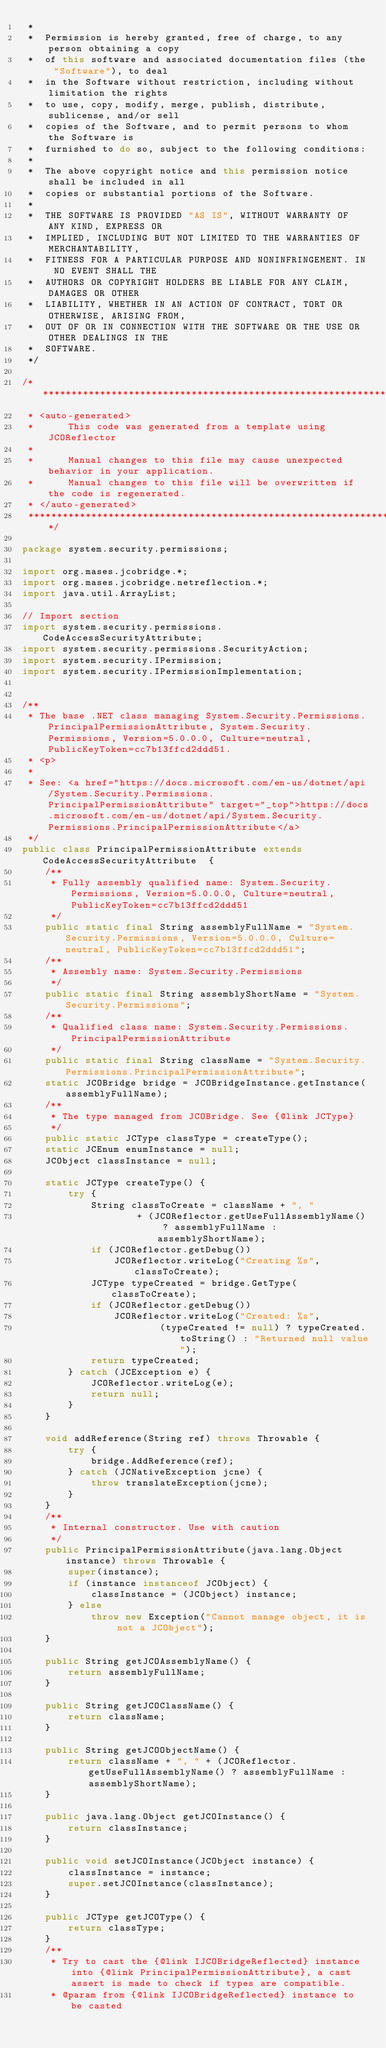<code> <loc_0><loc_0><loc_500><loc_500><_Java_> *
 *  Permission is hereby granted, free of charge, to any person obtaining a copy
 *  of this software and associated documentation files (the "Software"), to deal
 *  in the Software without restriction, including without limitation the rights
 *  to use, copy, modify, merge, publish, distribute, sublicense, and/or sell
 *  copies of the Software, and to permit persons to whom the Software is
 *  furnished to do so, subject to the following conditions:
 *
 *  The above copyright notice and this permission notice shall be included in all
 *  copies or substantial portions of the Software.
 *
 *  THE SOFTWARE IS PROVIDED "AS IS", WITHOUT WARRANTY OF ANY KIND, EXPRESS OR
 *  IMPLIED, INCLUDING BUT NOT LIMITED TO THE WARRANTIES OF MERCHANTABILITY,
 *  FITNESS FOR A PARTICULAR PURPOSE AND NONINFRINGEMENT. IN NO EVENT SHALL THE
 *  AUTHORS OR COPYRIGHT HOLDERS BE LIABLE FOR ANY CLAIM, DAMAGES OR OTHER
 *  LIABILITY, WHETHER IN AN ACTION OF CONTRACT, TORT OR OTHERWISE, ARISING FROM,
 *  OUT OF OR IN CONNECTION WITH THE SOFTWARE OR THE USE OR OTHER DEALINGS IN THE
 *  SOFTWARE.
 */

/**************************************************************************************
 * <auto-generated>
 *      This code was generated from a template using JCOReflector
 * 
 *      Manual changes to this file may cause unexpected behavior in your application.
 *      Manual changes to this file will be overwritten if the code is regenerated.
 * </auto-generated>
 *************************************************************************************/

package system.security.permissions;

import org.mases.jcobridge.*;
import org.mases.jcobridge.netreflection.*;
import java.util.ArrayList;

// Import section
import system.security.permissions.CodeAccessSecurityAttribute;
import system.security.permissions.SecurityAction;
import system.security.IPermission;
import system.security.IPermissionImplementation;


/**
 * The base .NET class managing System.Security.Permissions.PrincipalPermissionAttribute, System.Security.Permissions, Version=5.0.0.0, Culture=neutral, PublicKeyToken=cc7b13ffcd2ddd51.
 * <p>
 * 
 * See: <a href="https://docs.microsoft.com/en-us/dotnet/api/System.Security.Permissions.PrincipalPermissionAttribute" target="_top">https://docs.microsoft.com/en-us/dotnet/api/System.Security.Permissions.PrincipalPermissionAttribute</a>
 */
public class PrincipalPermissionAttribute extends CodeAccessSecurityAttribute  {
    /**
     * Fully assembly qualified name: System.Security.Permissions, Version=5.0.0.0, Culture=neutral, PublicKeyToken=cc7b13ffcd2ddd51
     */
    public static final String assemblyFullName = "System.Security.Permissions, Version=5.0.0.0, Culture=neutral, PublicKeyToken=cc7b13ffcd2ddd51";
    /**
     * Assembly name: System.Security.Permissions
     */
    public static final String assemblyShortName = "System.Security.Permissions";
    /**
     * Qualified class name: System.Security.Permissions.PrincipalPermissionAttribute
     */
    public static final String className = "System.Security.Permissions.PrincipalPermissionAttribute";
    static JCOBridge bridge = JCOBridgeInstance.getInstance(assemblyFullName);
    /**
     * The type managed from JCOBridge. See {@link JCType}
     */
    public static JCType classType = createType();
    static JCEnum enumInstance = null;
    JCObject classInstance = null;

    static JCType createType() {
        try {
            String classToCreate = className + ", "
                    + (JCOReflector.getUseFullAssemblyName() ? assemblyFullName : assemblyShortName);
            if (JCOReflector.getDebug())
                JCOReflector.writeLog("Creating %s", classToCreate);
            JCType typeCreated = bridge.GetType(classToCreate);
            if (JCOReflector.getDebug())
                JCOReflector.writeLog("Created: %s",
                        (typeCreated != null) ? typeCreated.toString() : "Returned null value");
            return typeCreated;
        } catch (JCException e) {
            JCOReflector.writeLog(e);
            return null;
        }
    }

    void addReference(String ref) throws Throwable {
        try {
            bridge.AddReference(ref);
        } catch (JCNativeException jcne) {
            throw translateException(jcne);
        }
    }
    /**
     * Internal constructor. Use with caution 
     */
    public PrincipalPermissionAttribute(java.lang.Object instance) throws Throwable {
        super(instance);
        if (instance instanceof JCObject) {
            classInstance = (JCObject) instance;
        } else
            throw new Exception("Cannot manage object, it is not a JCObject");
    }

    public String getJCOAssemblyName() {
        return assemblyFullName;
    }

    public String getJCOClassName() {
        return className;
    }

    public String getJCOObjectName() {
        return className + ", " + (JCOReflector.getUseFullAssemblyName() ? assemblyFullName : assemblyShortName);
    }

    public java.lang.Object getJCOInstance() {
        return classInstance;
    }

    public void setJCOInstance(JCObject instance) {
        classInstance = instance;
        super.setJCOInstance(classInstance);
    }

    public JCType getJCOType() {
        return classType;
    }
    /**
     * Try to cast the {@link IJCOBridgeReflected} instance into {@link PrincipalPermissionAttribute}, a cast assert is made to check if types are compatible.
     * @param from {@link IJCOBridgeReflected} instance to be casted</code> 